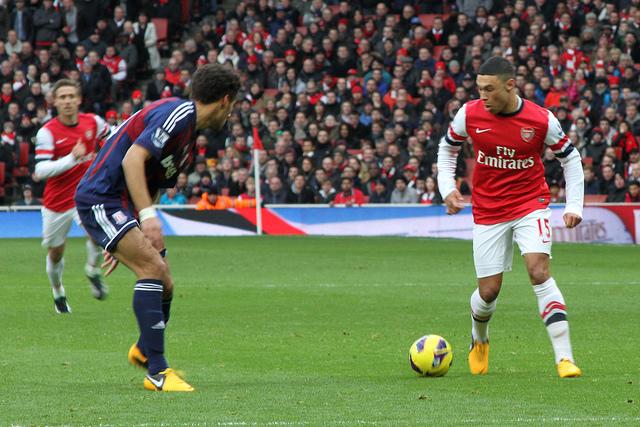What shoes color are the same?
Keep it brief. Yellow. Is one of the soccer teams from the United Emirates?
Keep it brief. Yes. Are there a lot of spectators?
Answer briefly. Yes. What color is the soccer ball?
Quick response, please. Yellow. 